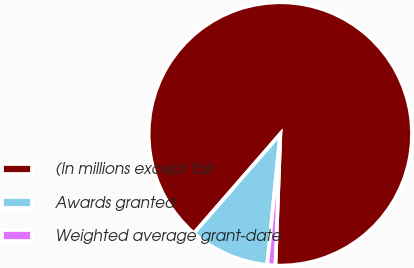Convert chart. <chart><loc_0><loc_0><loc_500><loc_500><pie_chart><fcel>(In millions except fair<fcel>Awards granted<fcel>Weighted average grant-date<nl><fcel>89.21%<fcel>9.81%<fcel>0.99%<nl></chart> 